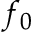Convert formula to latex. <formula><loc_0><loc_0><loc_500><loc_500>f _ { 0 }</formula> 